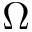<formula> <loc_0><loc_0><loc_500><loc_500>\Omega</formula> 